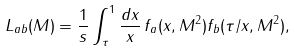<formula> <loc_0><loc_0><loc_500><loc_500>L _ { a b } ( M ) = \frac { 1 } { s } \int ^ { 1 } _ { \tau } \frac { d x } { x } \, f _ { a } ( x , M ^ { 2 } ) f _ { b } ( \tau / x , M ^ { 2 } ) ,</formula> 